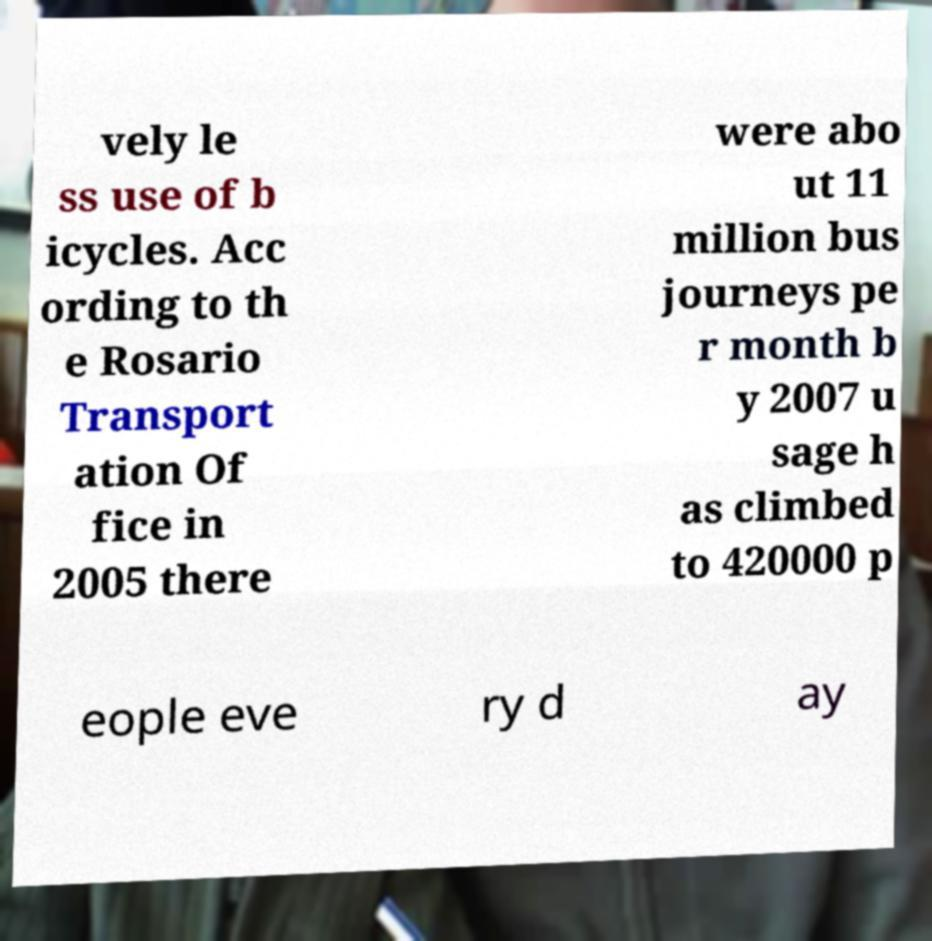Please read and relay the text visible in this image. What does it say? vely le ss use of b icycles. Acc ording to th e Rosario Transport ation Of fice in 2005 there were abo ut 11 million bus journeys pe r month b y 2007 u sage h as climbed to 420000 p eople eve ry d ay 